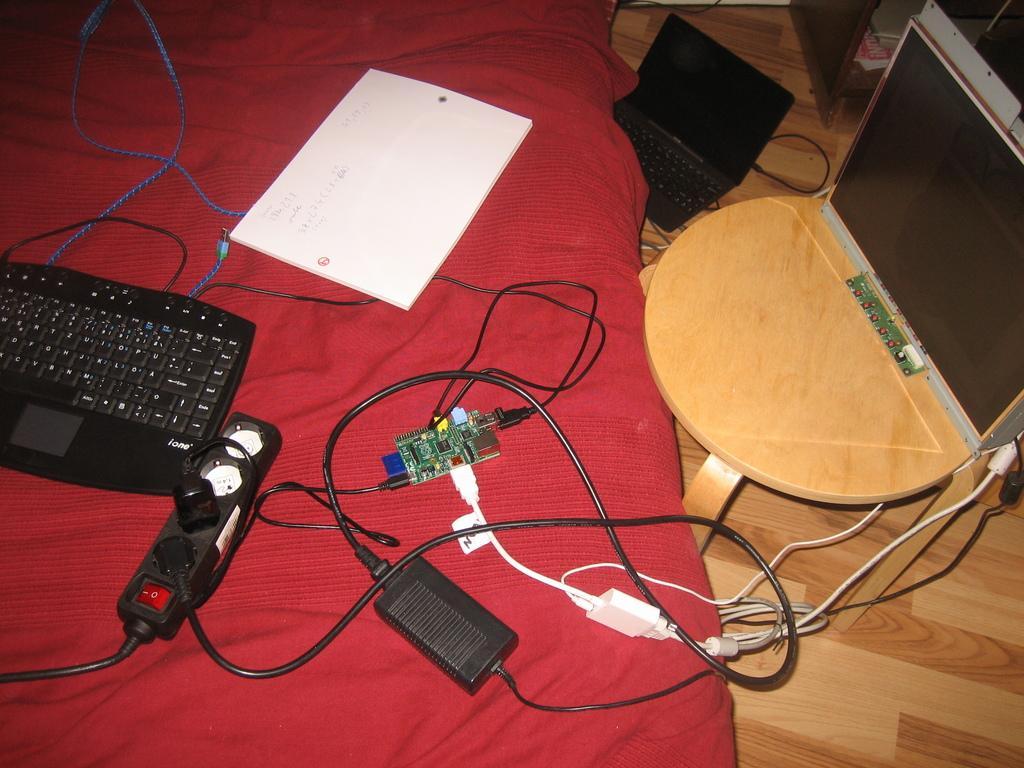Describe this image in one or two sentences. In this picture I can see a keyboard, socket board, a paper and an integrated circuit on the cloth. I can see a monitor on the stool and a laptop on the floor. 